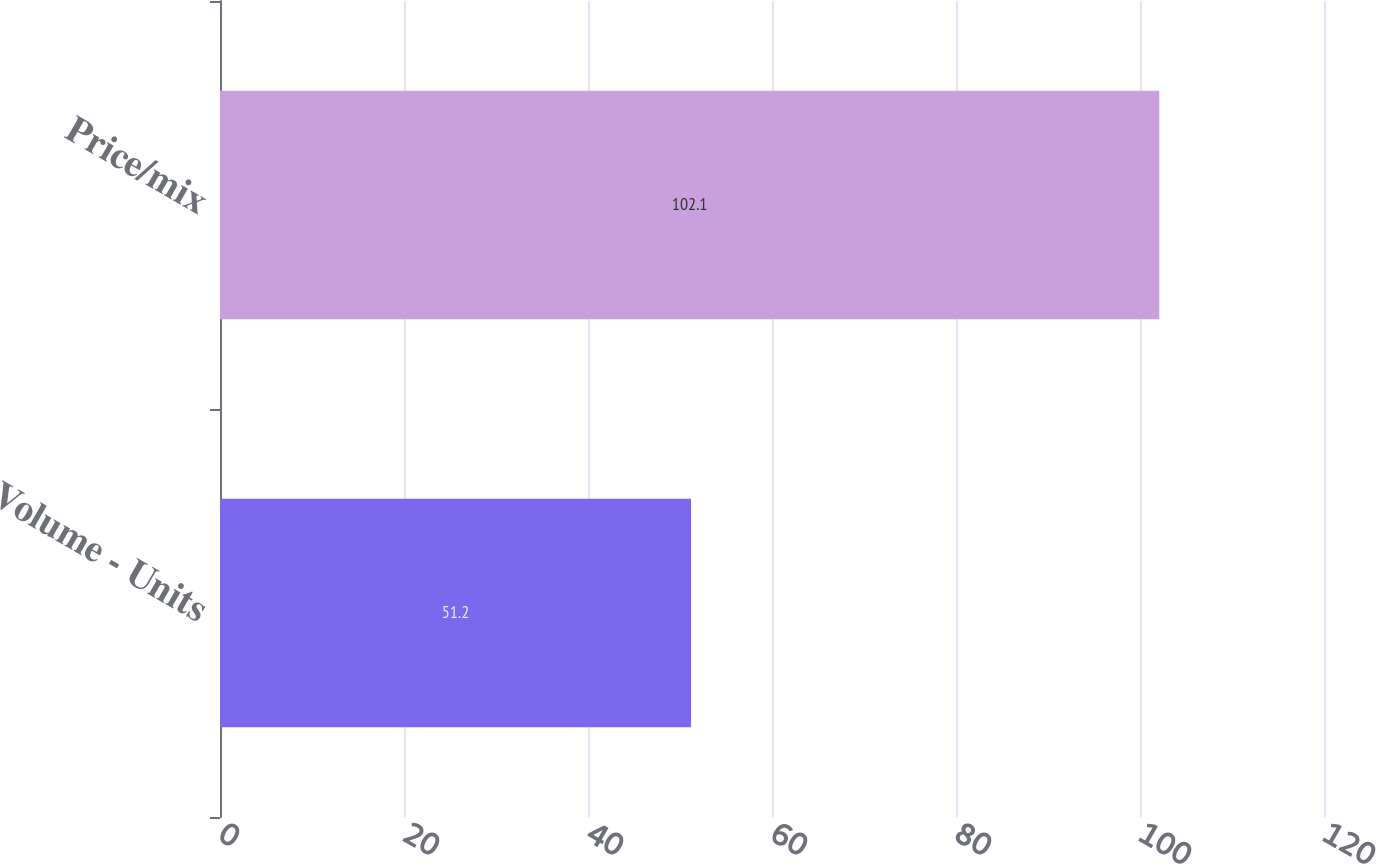<chart> <loc_0><loc_0><loc_500><loc_500><bar_chart><fcel>Volume - Units<fcel>Price/mix<nl><fcel>51.2<fcel>102.1<nl></chart> 